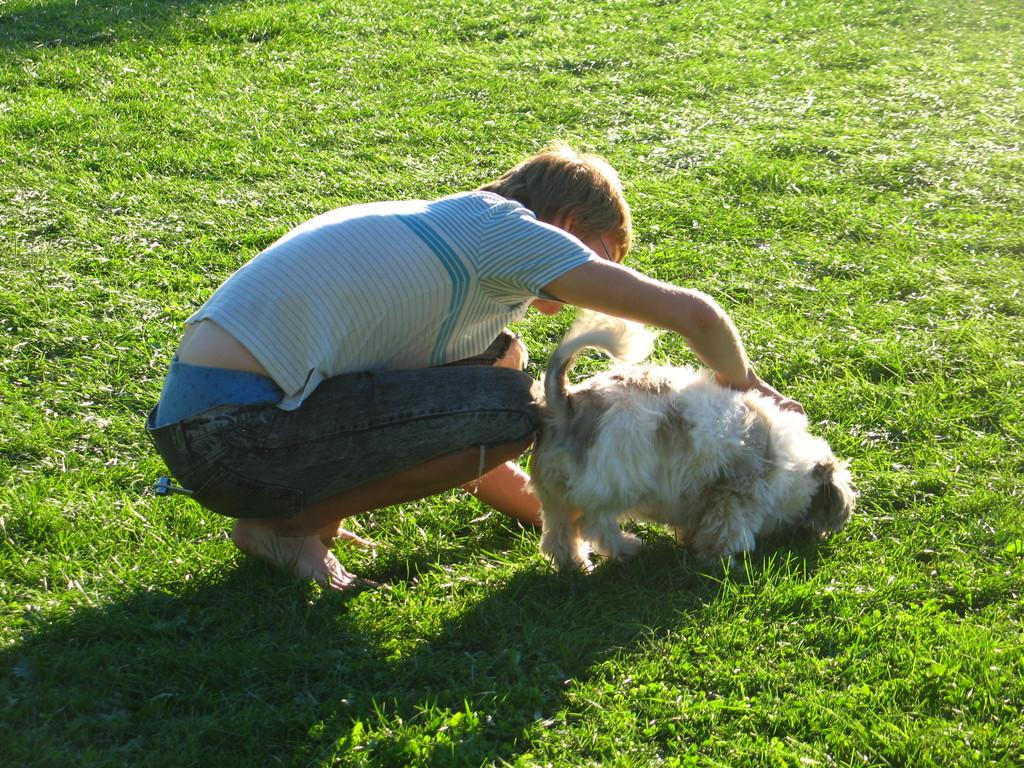Who or what is present in the image? There is a person and a dog in the image. What is the person wearing? The person is wearing a blue and white color shirt. What is the color of the dog? The dog is in cream and white color. What is the color of the grass in the image? The grass is green in the image. Is there a sweater-wearing army marching up a hill in the image? No, there is no sweater-wearing army or hill present in the image. The image features a person and a dog in a grassy area. 